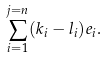Convert formula to latex. <formula><loc_0><loc_0><loc_500><loc_500>\sum _ { i = 1 } ^ { j = n } ( k _ { i } - l _ { i } ) e _ { i } .</formula> 